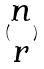<formula> <loc_0><loc_0><loc_500><loc_500>( \begin{matrix} n \\ r \end{matrix} )</formula> 